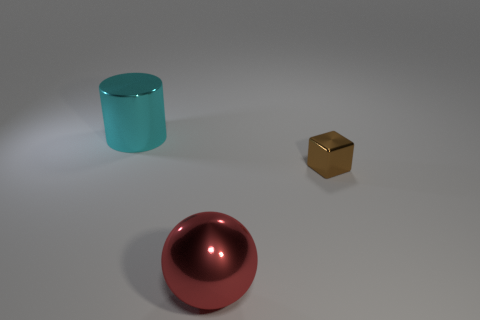Add 3 cyan cylinders. How many objects exist? 6 Add 2 metal spheres. How many metal spheres are left? 3 Add 1 small red shiny objects. How many small red shiny objects exist? 1 Subtract 0 blue blocks. How many objects are left? 3 Subtract all cubes. How many objects are left? 2 Subtract all gray balls. Subtract all cyan blocks. How many balls are left? 1 Subtract all blue blocks. How many yellow cylinders are left? 0 Subtract all large green matte blocks. Subtract all red objects. How many objects are left? 2 